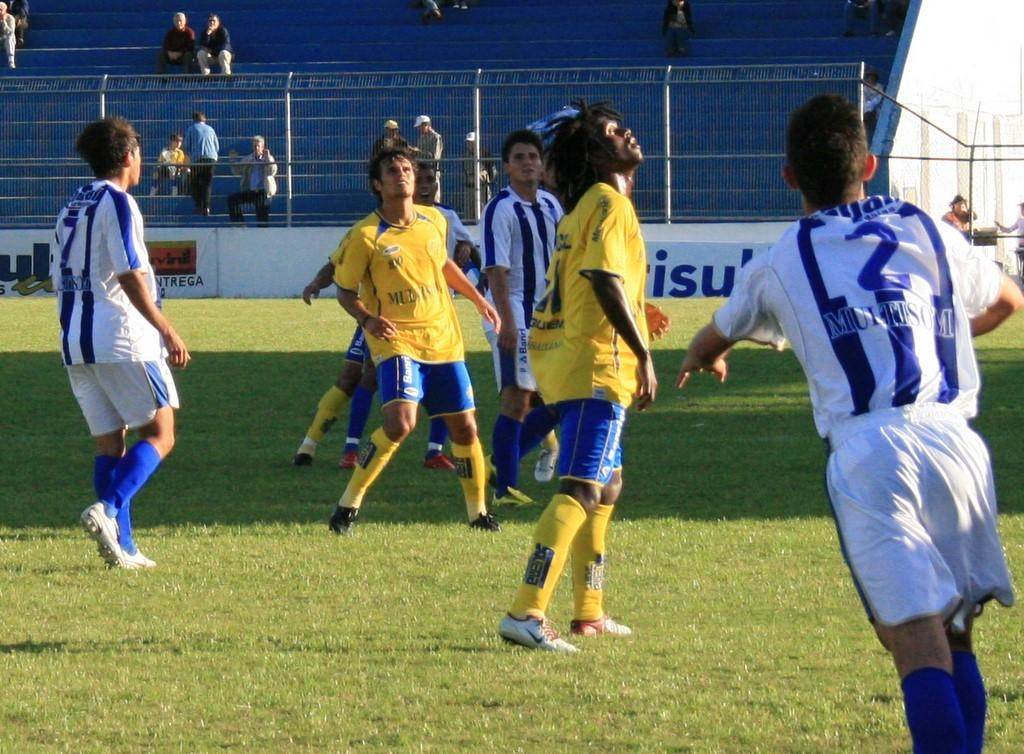Provide a one-sentence caption for the provided image. Several soccer players are on a field. One player's jersey number is 2. 